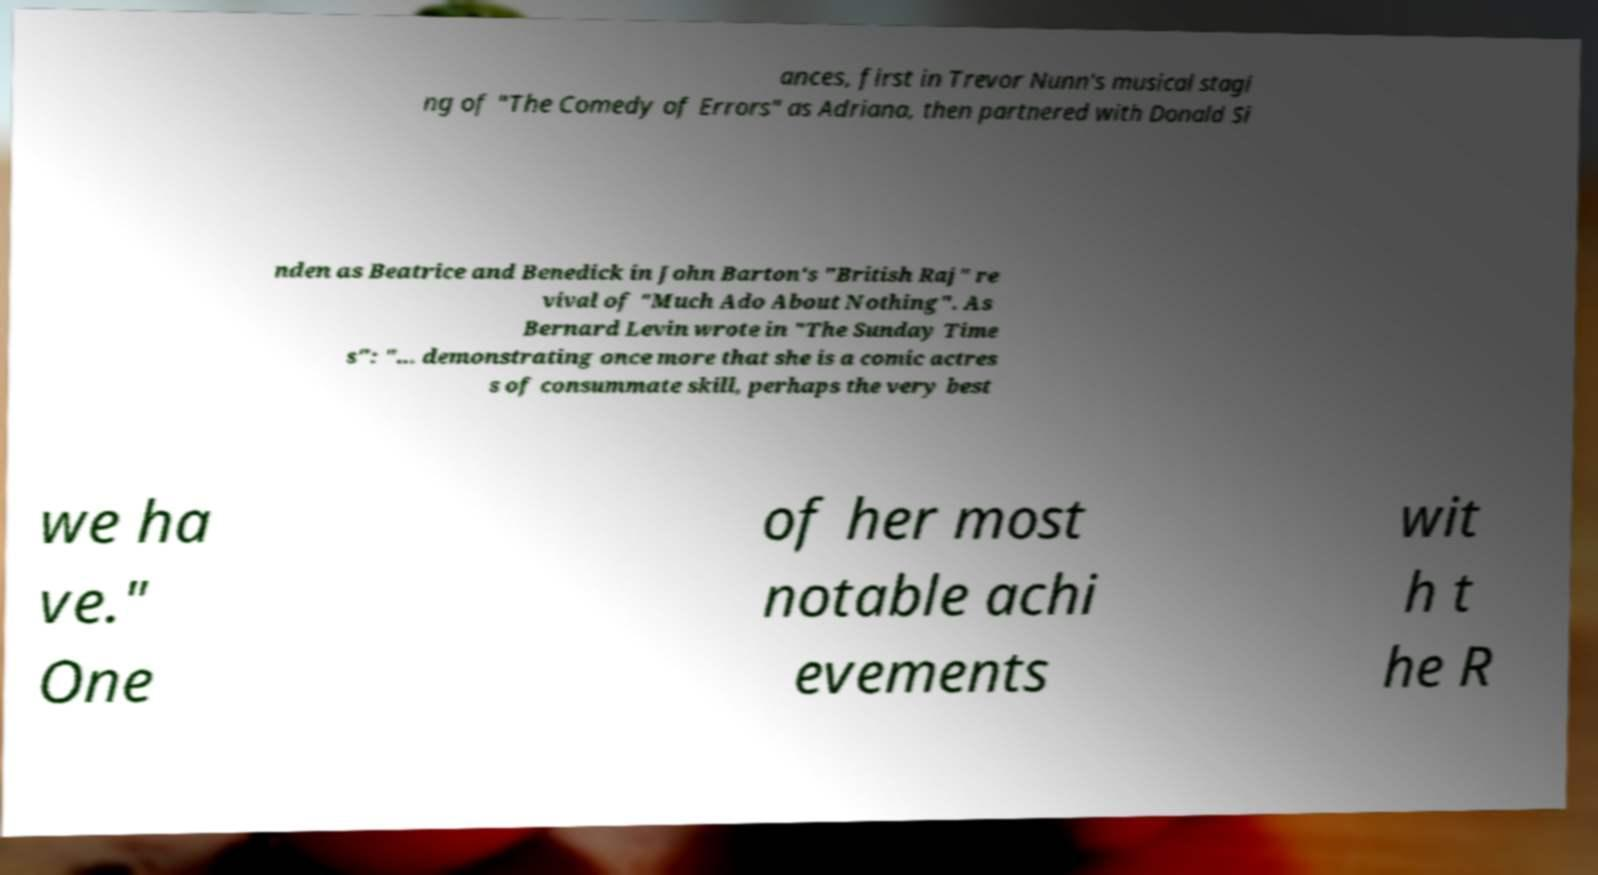Please identify and transcribe the text found in this image. ances, first in Trevor Nunn's musical stagi ng of "The Comedy of Errors" as Adriana, then partnered with Donald Si nden as Beatrice and Benedick in John Barton's "British Raj" re vival of "Much Ado About Nothing". As Bernard Levin wrote in "The Sunday Time s": "... demonstrating once more that she is a comic actres s of consummate skill, perhaps the very best we ha ve." One of her most notable achi evements wit h t he R 